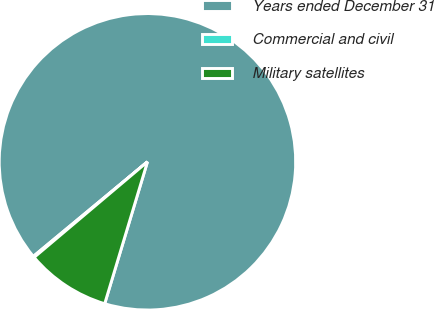<chart> <loc_0><loc_0><loc_500><loc_500><pie_chart><fcel>Years ended December 31<fcel>Commercial and civil<fcel>Military satellites<nl><fcel>90.68%<fcel>0.14%<fcel>9.19%<nl></chart> 